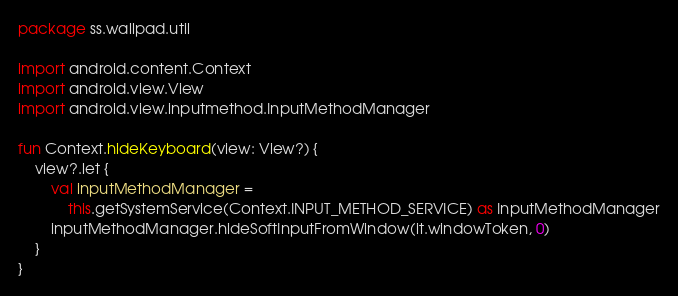Convert code to text. <code><loc_0><loc_0><loc_500><loc_500><_Kotlin_>package ss.wallpad.util

import android.content.Context
import android.view.View
import android.view.inputmethod.InputMethodManager

fun Context.hideKeyboard(view: View?) {
    view?.let {
        val inputMethodManager =
            this.getSystemService(Context.INPUT_METHOD_SERVICE) as InputMethodManager
        inputMethodManager.hideSoftInputFromWindow(it.windowToken, 0)
    }
}
</code> 